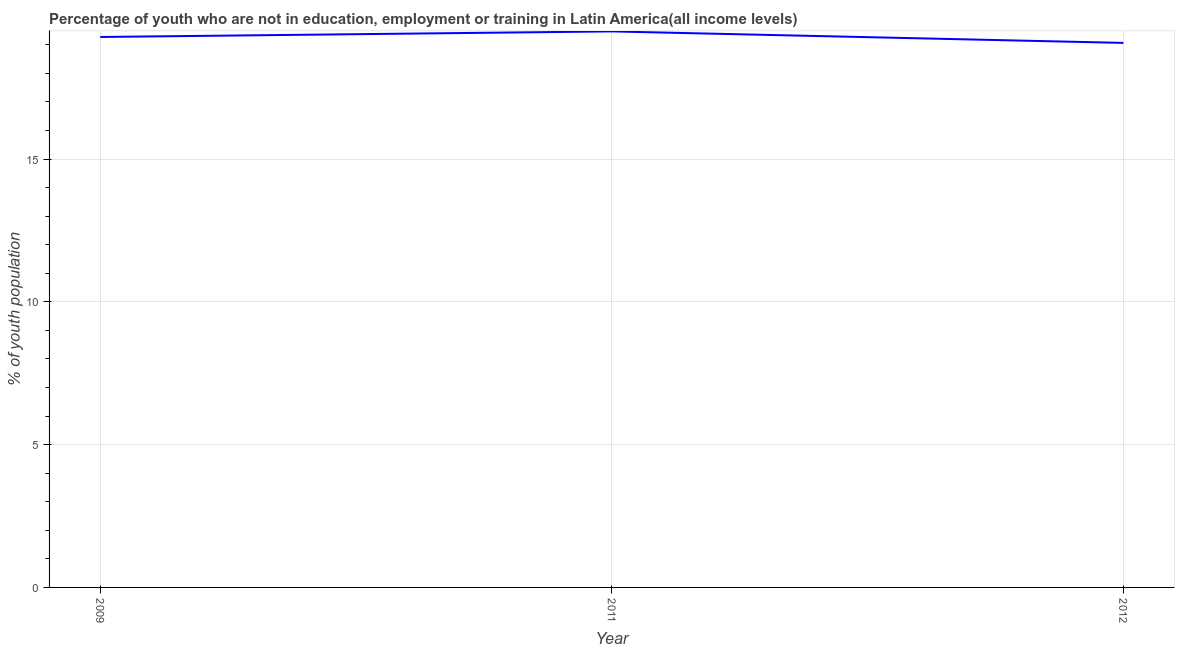What is the unemployed youth population in 2009?
Provide a short and direct response. 19.27. Across all years, what is the maximum unemployed youth population?
Offer a very short reply. 19.47. Across all years, what is the minimum unemployed youth population?
Provide a short and direct response. 19.07. In which year was the unemployed youth population minimum?
Your answer should be very brief. 2012. What is the sum of the unemployed youth population?
Provide a succinct answer. 57.81. What is the difference between the unemployed youth population in 2009 and 2011?
Offer a terse response. -0.2. What is the average unemployed youth population per year?
Ensure brevity in your answer.  19.27. What is the median unemployed youth population?
Offer a terse response. 19.27. In how many years, is the unemployed youth population greater than 13 %?
Offer a very short reply. 3. What is the ratio of the unemployed youth population in 2009 to that in 2011?
Provide a short and direct response. 0.99. What is the difference between the highest and the second highest unemployed youth population?
Keep it short and to the point. 0.2. Is the sum of the unemployed youth population in 2011 and 2012 greater than the maximum unemployed youth population across all years?
Make the answer very short. Yes. What is the difference between the highest and the lowest unemployed youth population?
Give a very brief answer. 0.4. In how many years, is the unemployed youth population greater than the average unemployed youth population taken over all years?
Make the answer very short. 2. How many years are there in the graph?
Provide a succinct answer. 3. What is the difference between two consecutive major ticks on the Y-axis?
Your response must be concise. 5. Are the values on the major ticks of Y-axis written in scientific E-notation?
Offer a very short reply. No. Does the graph contain any zero values?
Give a very brief answer. No. What is the title of the graph?
Offer a terse response. Percentage of youth who are not in education, employment or training in Latin America(all income levels). What is the label or title of the X-axis?
Your answer should be compact. Year. What is the label or title of the Y-axis?
Give a very brief answer. % of youth population. What is the % of youth population in 2009?
Keep it short and to the point. 19.27. What is the % of youth population of 2011?
Keep it short and to the point. 19.47. What is the % of youth population in 2012?
Offer a very short reply. 19.07. What is the difference between the % of youth population in 2009 and 2011?
Your answer should be compact. -0.2. What is the difference between the % of youth population in 2009 and 2012?
Give a very brief answer. 0.21. What is the difference between the % of youth population in 2011 and 2012?
Offer a very short reply. 0.4. What is the ratio of the % of youth population in 2009 to that in 2011?
Keep it short and to the point. 0.99. What is the ratio of the % of youth population in 2009 to that in 2012?
Make the answer very short. 1.01. 